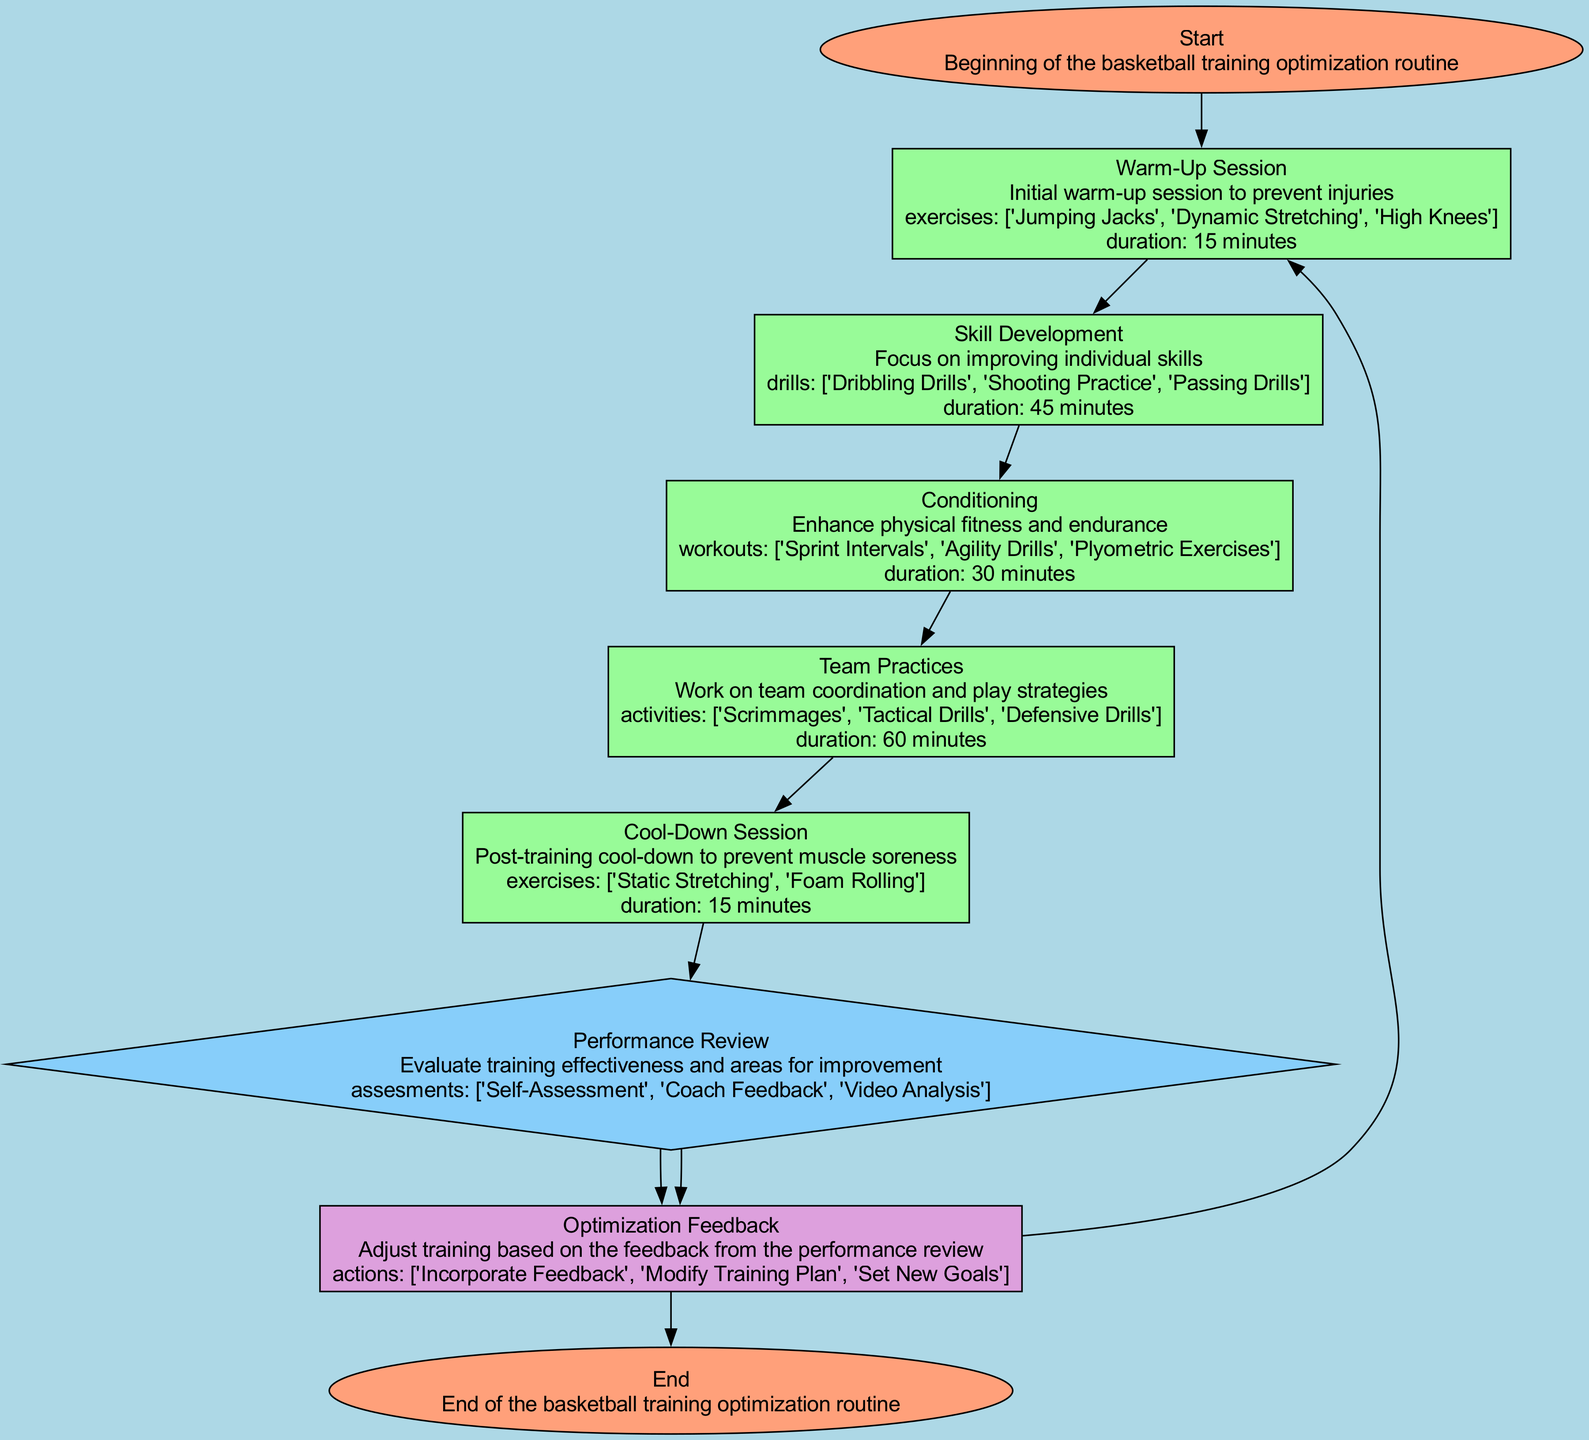What is the first step in the basketball training optimization routine? The first step in the flow chart is labeled "Start," indicating the beginning of the basketball training optimization routine.
Answer: Start How long does the Warm-Up Session last? The diagram states that the duration of the Warm-Up Session is 15 minutes, as detailed in the relevant node.
Answer: 15 minutes Which activities are included in Team Practices? According to the "Team Practices" node, the activities listed are "Scrimmages," "Tactical Drills," and "Defensive Drills."
Answer: Scrimmages, Tactical Drills, Defensive Drills What process comes after Skill Development? The flow chart indicates that after Skill Development, the next process is "Conditioning," which is the subsequent node in the sequence.
Answer: Conditioning What is the purpose of the Performance Review? The node labeled "Performance Review" describes its purpose as evaluating training effectiveness and areas for improvement, indicating it's a decision-making point in the routine.
Answer: Evaluate training effectiveness What actions are included in the Optimization Feedback? The "Optimization Feedback" node lists the actions as "Incorporate Feedback," "Modify Training Plan," and "Set New Goals."
Answer: Incorporate Feedback, Modify Training Plan, Set New Goals How many main processes are there before the Cool-Down Session? The diagram indicates that there are four main processes (Warm-Up Session, Skill Development, Conditioning, Team Practices) before reaching the Cool-Down Session.
Answer: Four What type of node is the End represented by in the flow chart? The "End" in the flow chart is represented as an oval, which is the shape used for end nodes according to the diagram's style.
Answer: Oval What feedback loop exists in this training routine? The flow chart shows a feedback loop that connects "Performance Review" to "Optimization Feedback," indicating that feedback can lead back to the Warm-Up Session for adjustments.
Answer: Performance Review to Optimization Feedback 